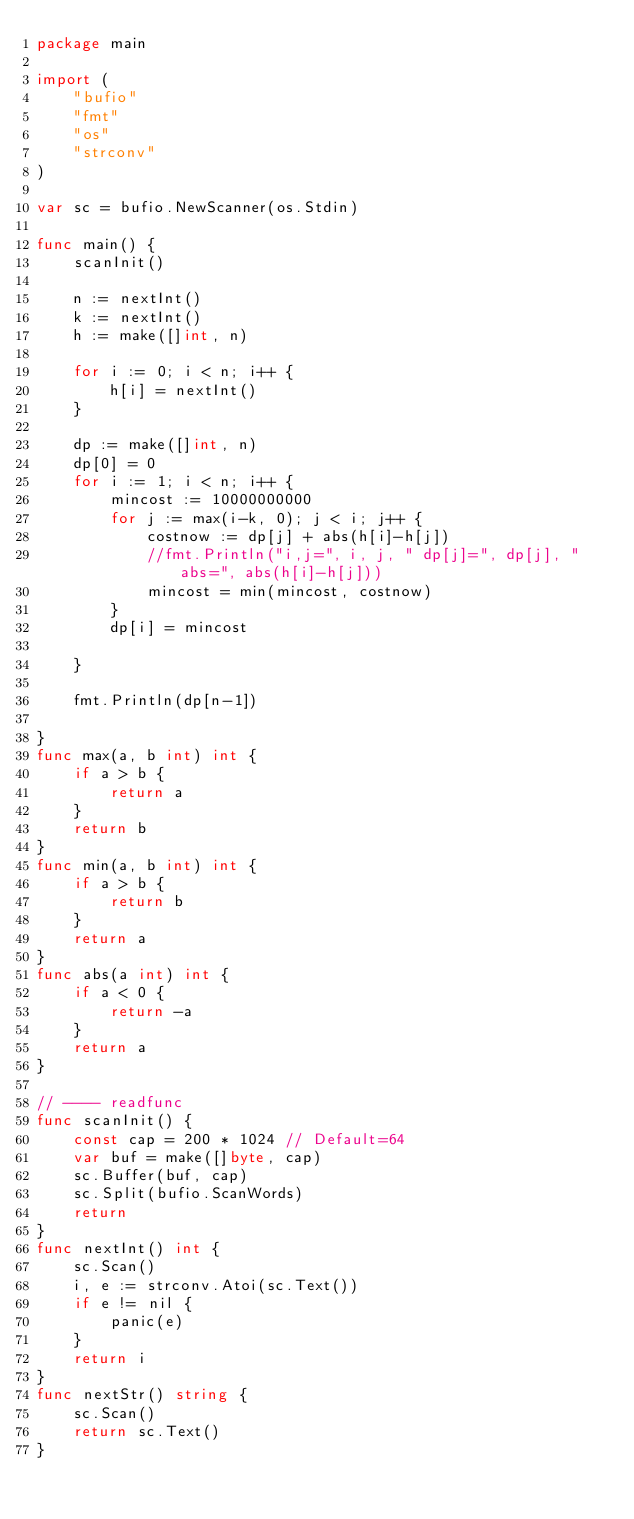Convert code to text. <code><loc_0><loc_0><loc_500><loc_500><_Go_>package main

import (
	"bufio"
	"fmt"
	"os"
	"strconv"
)

var sc = bufio.NewScanner(os.Stdin)

func main() {
	scanInit()

	n := nextInt()
	k := nextInt()
	h := make([]int, n)

	for i := 0; i < n; i++ {
		h[i] = nextInt()
	}

	dp := make([]int, n)
	dp[0] = 0
	for i := 1; i < n; i++ {
		mincost := 10000000000
		for j := max(i-k, 0); j < i; j++ {
			costnow := dp[j] + abs(h[i]-h[j])
			//fmt.Println("i,j=", i, j, " dp[j]=", dp[j], " abs=", abs(h[i]-h[j]))
			mincost = min(mincost, costnow)
		}
		dp[i] = mincost

	}

	fmt.Println(dp[n-1])

}
func max(a, b int) int {
	if a > b {
		return a
	}
	return b
}
func min(a, b int) int {
	if a > b {
		return b
	}
	return a
}
func abs(a int) int {
	if a < 0 {
		return -a
	}
	return a
}

// ---- readfunc
func scanInit() {
	const cap = 200 * 1024 // Default=64
	var buf = make([]byte, cap)
	sc.Buffer(buf, cap)
	sc.Split(bufio.ScanWords)
	return
}
func nextInt() int {
	sc.Scan()
	i, e := strconv.Atoi(sc.Text())
	if e != nil {
		panic(e)
	}
	return i
}
func nextStr() string {
	sc.Scan()
	return sc.Text()
}
</code> 